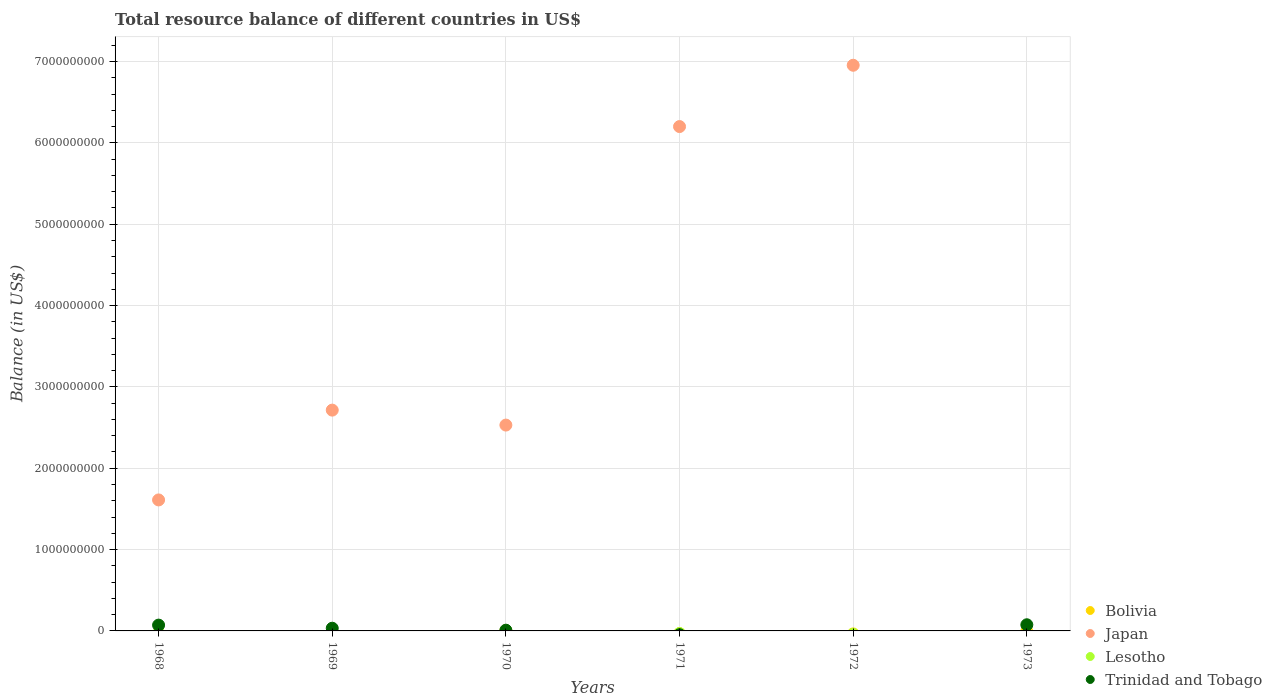How many different coloured dotlines are there?
Your response must be concise. 3. Across all years, what is the maximum total resource balance in Bolivia?
Your answer should be very brief. 2.44e+06. Across all years, what is the minimum total resource balance in Bolivia?
Keep it short and to the point. 0. In which year was the total resource balance in Trinidad and Tobago maximum?
Keep it short and to the point. 1973. What is the total total resource balance in Bolivia in the graph?
Your answer should be compact. 2.44e+06. What is the difference between the total resource balance in Trinidad and Tobago in 1970 and that in 1973?
Offer a very short reply. -6.66e+07. What is the difference between the total resource balance in Trinidad and Tobago in 1973 and the total resource balance in Bolivia in 1972?
Make the answer very short. 7.57e+07. What is the average total resource balance in Japan per year?
Offer a very short reply. 3.33e+09. In the year 1970, what is the difference between the total resource balance in Trinidad and Tobago and total resource balance in Bolivia?
Your answer should be compact. 6.61e+06. What is the difference between the highest and the second highest total resource balance in Trinidad and Tobago?
Offer a very short reply. 4.29e+06. What is the difference between the highest and the lowest total resource balance in Trinidad and Tobago?
Keep it short and to the point. 7.57e+07. Does the total resource balance in Lesotho monotonically increase over the years?
Give a very brief answer. No. Is the total resource balance in Bolivia strictly greater than the total resource balance in Lesotho over the years?
Offer a very short reply. No. Is the total resource balance in Bolivia strictly less than the total resource balance in Lesotho over the years?
Provide a succinct answer. No. What is the difference between two consecutive major ticks on the Y-axis?
Give a very brief answer. 1.00e+09. Does the graph contain grids?
Give a very brief answer. Yes. Where does the legend appear in the graph?
Offer a terse response. Bottom right. How many legend labels are there?
Make the answer very short. 4. What is the title of the graph?
Provide a succinct answer. Total resource balance of different countries in US$. Does "Euro area" appear as one of the legend labels in the graph?
Keep it short and to the point. No. What is the label or title of the X-axis?
Ensure brevity in your answer.  Years. What is the label or title of the Y-axis?
Offer a very short reply. Balance (in US$). What is the Balance (in US$) of Bolivia in 1968?
Give a very brief answer. 0. What is the Balance (in US$) in Japan in 1968?
Offer a very short reply. 1.61e+09. What is the Balance (in US$) of Trinidad and Tobago in 1968?
Provide a short and direct response. 7.14e+07. What is the Balance (in US$) of Bolivia in 1969?
Provide a short and direct response. 0. What is the Balance (in US$) of Japan in 1969?
Your response must be concise. 2.71e+09. What is the Balance (in US$) of Lesotho in 1969?
Ensure brevity in your answer.  0. What is the Balance (in US$) of Trinidad and Tobago in 1969?
Offer a very short reply. 3.31e+07. What is the Balance (in US$) in Bolivia in 1970?
Give a very brief answer. 2.44e+06. What is the Balance (in US$) in Japan in 1970?
Your answer should be very brief. 2.53e+09. What is the Balance (in US$) of Lesotho in 1970?
Your answer should be very brief. 0. What is the Balance (in US$) in Trinidad and Tobago in 1970?
Ensure brevity in your answer.  9.05e+06. What is the Balance (in US$) in Bolivia in 1971?
Give a very brief answer. 0. What is the Balance (in US$) of Japan in 1971?
Ensure brevity in your answer.  6.20e+09. What is the Balance (in US$) of Lesotho in 1971?
Keep it short and to the point. 0. What is the Balance (in US$) in Japan in 1972?
Offer a very short reply. 6.95e+09. What is the Balance (in US$) of Bolivia in 1973?
Give a very brief answer. 0. What is the Balance (in US$) of Japan in 1973?
Make the answer very short. 0. What is the Balance (in US$) of Lesotho in 1973?
Ensure brevity in your answer.  0. What is the Balance (in US$) of Trinidad and Tobago in 1973?
Keep it short and to the point. 7.57e+07. Across all years, what is the maximum Balance (in US$) of Bolivia?
Keep it short and to the point. 2.44e+06. Across all years, what is the maximum Balance (in US$) in Japan?
Offer a terse response. 6.95e+09. Across all years, what is the maximum Balance (in US$) in Trinidad and Tobago?
Keep it short and to the point. 7.57e+07. Across all years, what is the minimum Balance (in US$) in Bolivia?
Give a very brief answer. 0. Across all years, what is the minimum Balance (in US$) of Trinidad and Tobago?
Keep it short and to the point. 0. What is the total Balance (in US$) of Bolivia in the graph?
Ensure brevity in your answer.  2.44e+06. What is the total Balance (in US$) in Japan in the graph?
Make the answer very short. 2.00e+1. What is the total Balance (in US$) in Trinidad and Tobago in the graph?
Provide a short and direct response. 1.89e+08. What is the difference between the Balance (in US$) in Japan in 1968 and that in 1969?
Make the answer very short. -1.10e+09. What is the difference between the Balance (in US$) in Trinidad and Tobago in 1968 and that in 1969?
Provide a succinct answer. 3.83e+07. What is the difference between the Balance (in US$) in Japan in 1968 and that in 1970?
Keep it short and to the point. -9.20e+08. What is the difference between the Balance (in US$) of Trinidad and Tobago in 1968 and that in 1970?
Provide a short and direct response. 6.24e+07. What is the difference between the Balance (in US$) in Japan in 1968 and that in 1971?
Give a very brief answer. -4.59e+09. What is the difference between the Balance (in US$) in Japan in 1968 and that in 1972?
Keep it short and to the point. -5.34e+09. What is the difference between the Balance (in US$) in Trinidad and Tobago in 1968 and that in 1973?
Keep it short and to the point. -4.29e+06. What is the difference between the Balance (in US$) of Japan in 1969 and that in 1970?
Your response must be concise. 1.84e+08. What is the difference between the Balance (in US$) in Trinidad and Tobago in 1969 and that in 1970?
Offer a very short reply. 2.40e+07. What is the difference between the Balance (in US$) in Japan in 1969 and that in 1971?
Your answer should be very brief. -3.49e+09. What is the difference between the Balance (in US$) of Japan in 1969 and that in 1972?
Provide a short and direct response. -4.24e+09. What is the difference between the Balance (in US$) of Trinidad and Tobago in 1969 and that in 1973?
Your answer should be very brief. -4.26e+07. What is the difference between the Balance (in US$) of Japan in 1970 and that in 1971?
Give a very brief answer. -3.67e+09. What is the difference between the Balance (in US$) of Japan in 1970 and that in 1972?
Keep it short and to the point. -4.42e+09. What is the difference between the Balance (in US$) of Trinidad and Tobago in 1970 and that in 1973?
Offer a very short reply. -6.66e+07. What is the difference between the Balance (in US$) in Japan in 1971 and that in 1972?
Keep it short and to the point. -7.54e+08. What is the difference between the Balance (in US$) in Japan in 1968 and the Balance (in US$) in Trinidad and Tobago in 1969?
Keep it short and to the point. 1.58e+09. What is the difference between the Balance (in US$) in Japan in 1968 and the Balance (in US$) in Trinidad and Tobago in 1970?
Your answer should be very brief. 1.60e+09. What is the difference between the Balance (in US$) in Japan in 1968 and the Balance (in US$) in Trinidad and Tobago in 1973?
Provide a succinct answer. 1.53e+09. What is the difference between the Balance (in US$) in Japan in 1969 and the Balance (in US$) in Trinidad and Tobago in 1970?
Keep it short and to the point. 2.71e+09. What is the difference between the Balance (in US$) in Japan in 1969 and the Balance (in US$) in Trinidad and Tobago in 1973?
Make the answer very short. 2.64e+09. What is the difference between the Balance (in US$) in Bolivia in 1970 and the Balance (in US$) in Japan in 1971?
Your response must be concise. -6.20e+09. What is the difference between the Balance (in US$) in Bolivia in 1970 and the Balance (in US$) in Japan in 1972?
Offer a very short reply. -6.95e+09. What is the difference between the Balance (in US$) of Bolivia in 1970 and the Balance (in US$) of Trinidad and Tobago in 1973?
Make the answer very short. -7.33e+07. What is the difference between the Balance (in US$) in Japan in 1970 and the Balance (in US$) in Trinidad and Tobago in 1973?
Your response must be concise. 2.45e+09. What is the difference between the Balance (in US$) of Japan in 1971 and the Balance (in US$) of Trinidad and Tobago in 1973?
Make the answer very short. 6.12e+09. What is the difference between the Balance (in US$) in Japan in 1972 and the Balance (in US$) in Trinidad and Tobago in 1973?
Give a very brief answer. 6.88e+09. What is the average Balance (in US$) in Bolivia per year?
Your answer should be compact. 4.07e+05. What is the average Balance (in US$) of Japan per year?
Your answer should be very brief. 3.33e+09. What is the average Balance (in US$) of Trinidad and Tobago per year?
Make the answer very short. 3.15e+07. In the year 1968, what is the difference between the Balance (in US$) in Japan and Balance (in US$) in Trinidad and Tobago?
Keep it short and to the point. 1.54e+09. In the year 1969, what is the difference between the Balance (in US$) in Japan and Balance (in US$) in Trinidad and Tobago?
Your answer should be compact. 2.68e+09. In the year 1970, what is the difference between the Balance (in US$) of Bolivia and Balance (in US$) of Japan?
Give a very brief answer. -2.53e+09. In the year 1970, what is the difference between the Balance (in US$) of Bolivia and Balance (in US$) of Trinidad and Tobago?
Offer a very short reply. -6.61e+06. In the year 1970, what is the difference between the Balance (in US$) of Japan and Balance (in US$) of Trinidad and Tobago?
Make the answer very short. 2.52e+09. What is the ratio of the Balance (in US$) of Japan in 1968 to that in 1969?
Offer a very short reply. 0.59. What is the ratio of the Balance (in US$) in Trinidad and Tobago in 1968 to that in 1969?
Your answer should be very brief. 2.16. What is the ratio of the Balance (in US$) of Japan in 1968 to that in 1970?
Ensure brevity in your answer.  0.64. What is the ratio of the Balance (in US$) of Trinidad and Tobago in 1968 to that in 1970?
Your answer should be very brief. 7.89. What is the ratio of the Balance (in US$) in Japan in 1968 to that in 1971?
Provide a short and direct response. 0.26. What is the ratio of the Balance (in US$) in Japan in 1968 to that in 1972?
Provide a short and direct response. 0.23. What is the ratio of the Balance (in US$) in Trinidad and Tobago in 1968 to that in 1973?
Make the answer very short. 0.94. What is the ratio of the Balance (in US$) of Japan in 1969 to that in 1970?
Ensure brevity in your answer.  1.07. What is the ratio of the Balance (in US$) in Trinidad and Tobago in 1969 to that in 1970?
Your response must be concise. 3.66. What is the ratio of the Balance (in US$) of Japan in 1969 to that in 1971?
Give a very brief answer. 0.44. What is the ratio of the Balance (in US$) in Japan in 1969 to that in 1972?
Offer a terse response. 0.39. What is the ratio of the Balance (in US$) of Trinidad and Tobago in 1969 to that in 1973?
Ensure brevity in your answer.  0.44. What is the ratio of the Balance (in US$) of Japan in 1970 to that in 1971?
Keep it short and to the point. 0.41. What is the ratio of the Balance (in US$) in Japan in 1970 to that in 1972?
Provide a short and direct response. 0.36. What is the ratio of the Balance (in US$) of Trinidad and Tobago in 1970 to that in 1973?
Your response must be concise. 0.12. What is the ratio of the Balance (in US$) of Japan in 1971 to that in 1972?
Your response must be concise. 0.89. What is the difference between the highest and the second highest Balance (in US$) in Japan?
Your answer should be compact. 7.54e+08. What is the difference between the highest and the second highest Balance (in US$) of Trinidad and Tobago?
Give a very brief answer. 4.29e+06. What is the difference between the highest and the lowest Balance (in US$) in Bolivia?
Your response must be concise. 2.44e+06. What is the difference between the highest and the lowest Balance (in US$) of Japan?
Offer a very short reply. 6.95e+09. What is the difference between the highest and the lowest Balance (in US$) in Trinidad and Tobago?
Provide a succinct answer. 7.57e+07. 